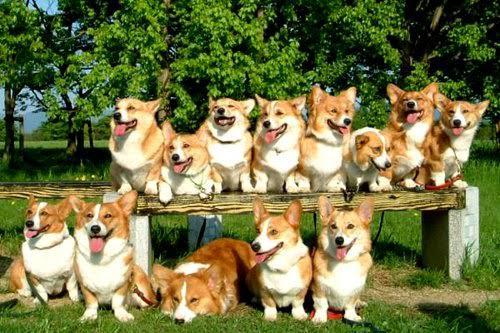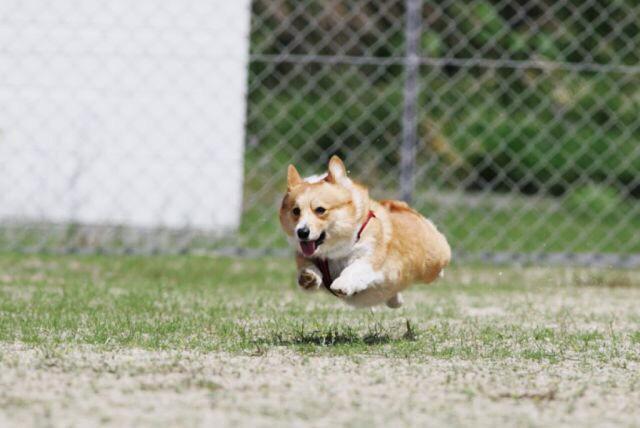The first image is the image on the left, the second image is the image on the right. Evaluate the accuracy of this statement regarding the images: "There are no more than 7 dogs in total.". Is it true? Answer yes or no. No. 